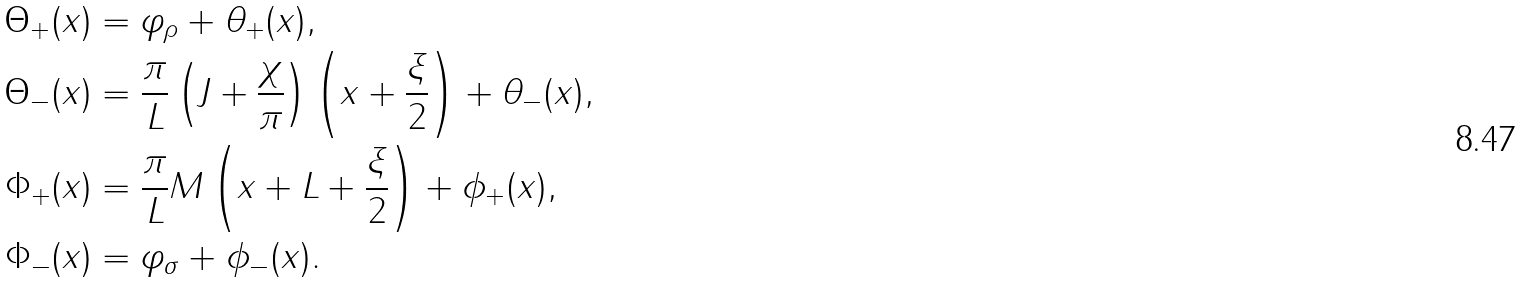<formula> <loc_0><loc_0><loc_500><loc_500>\Theta _ { + } ( x ) & = \varphi _ { \rho } + \theta _ { + } ( x ) , \\ \Theta _ { - } ( x ) & = \frac { \pi } { L } \left ( J + \frac { \chi } { \pi } \right ) \left ( x + \frac { \xi } { 2 } \right ) + \theta _ { - } ( x ) , \\ \Phi _ { + } ( x ) & = \frac { \pi } { L } M \left ( x + L + \frac { \xi } { 2 } \right ) + \phi _ { + } ( x ) , \\ \Phi _ { - } ( x ) & = \varphi _ { \sigma } + \phi _ { - } ( x ) .</formula> 